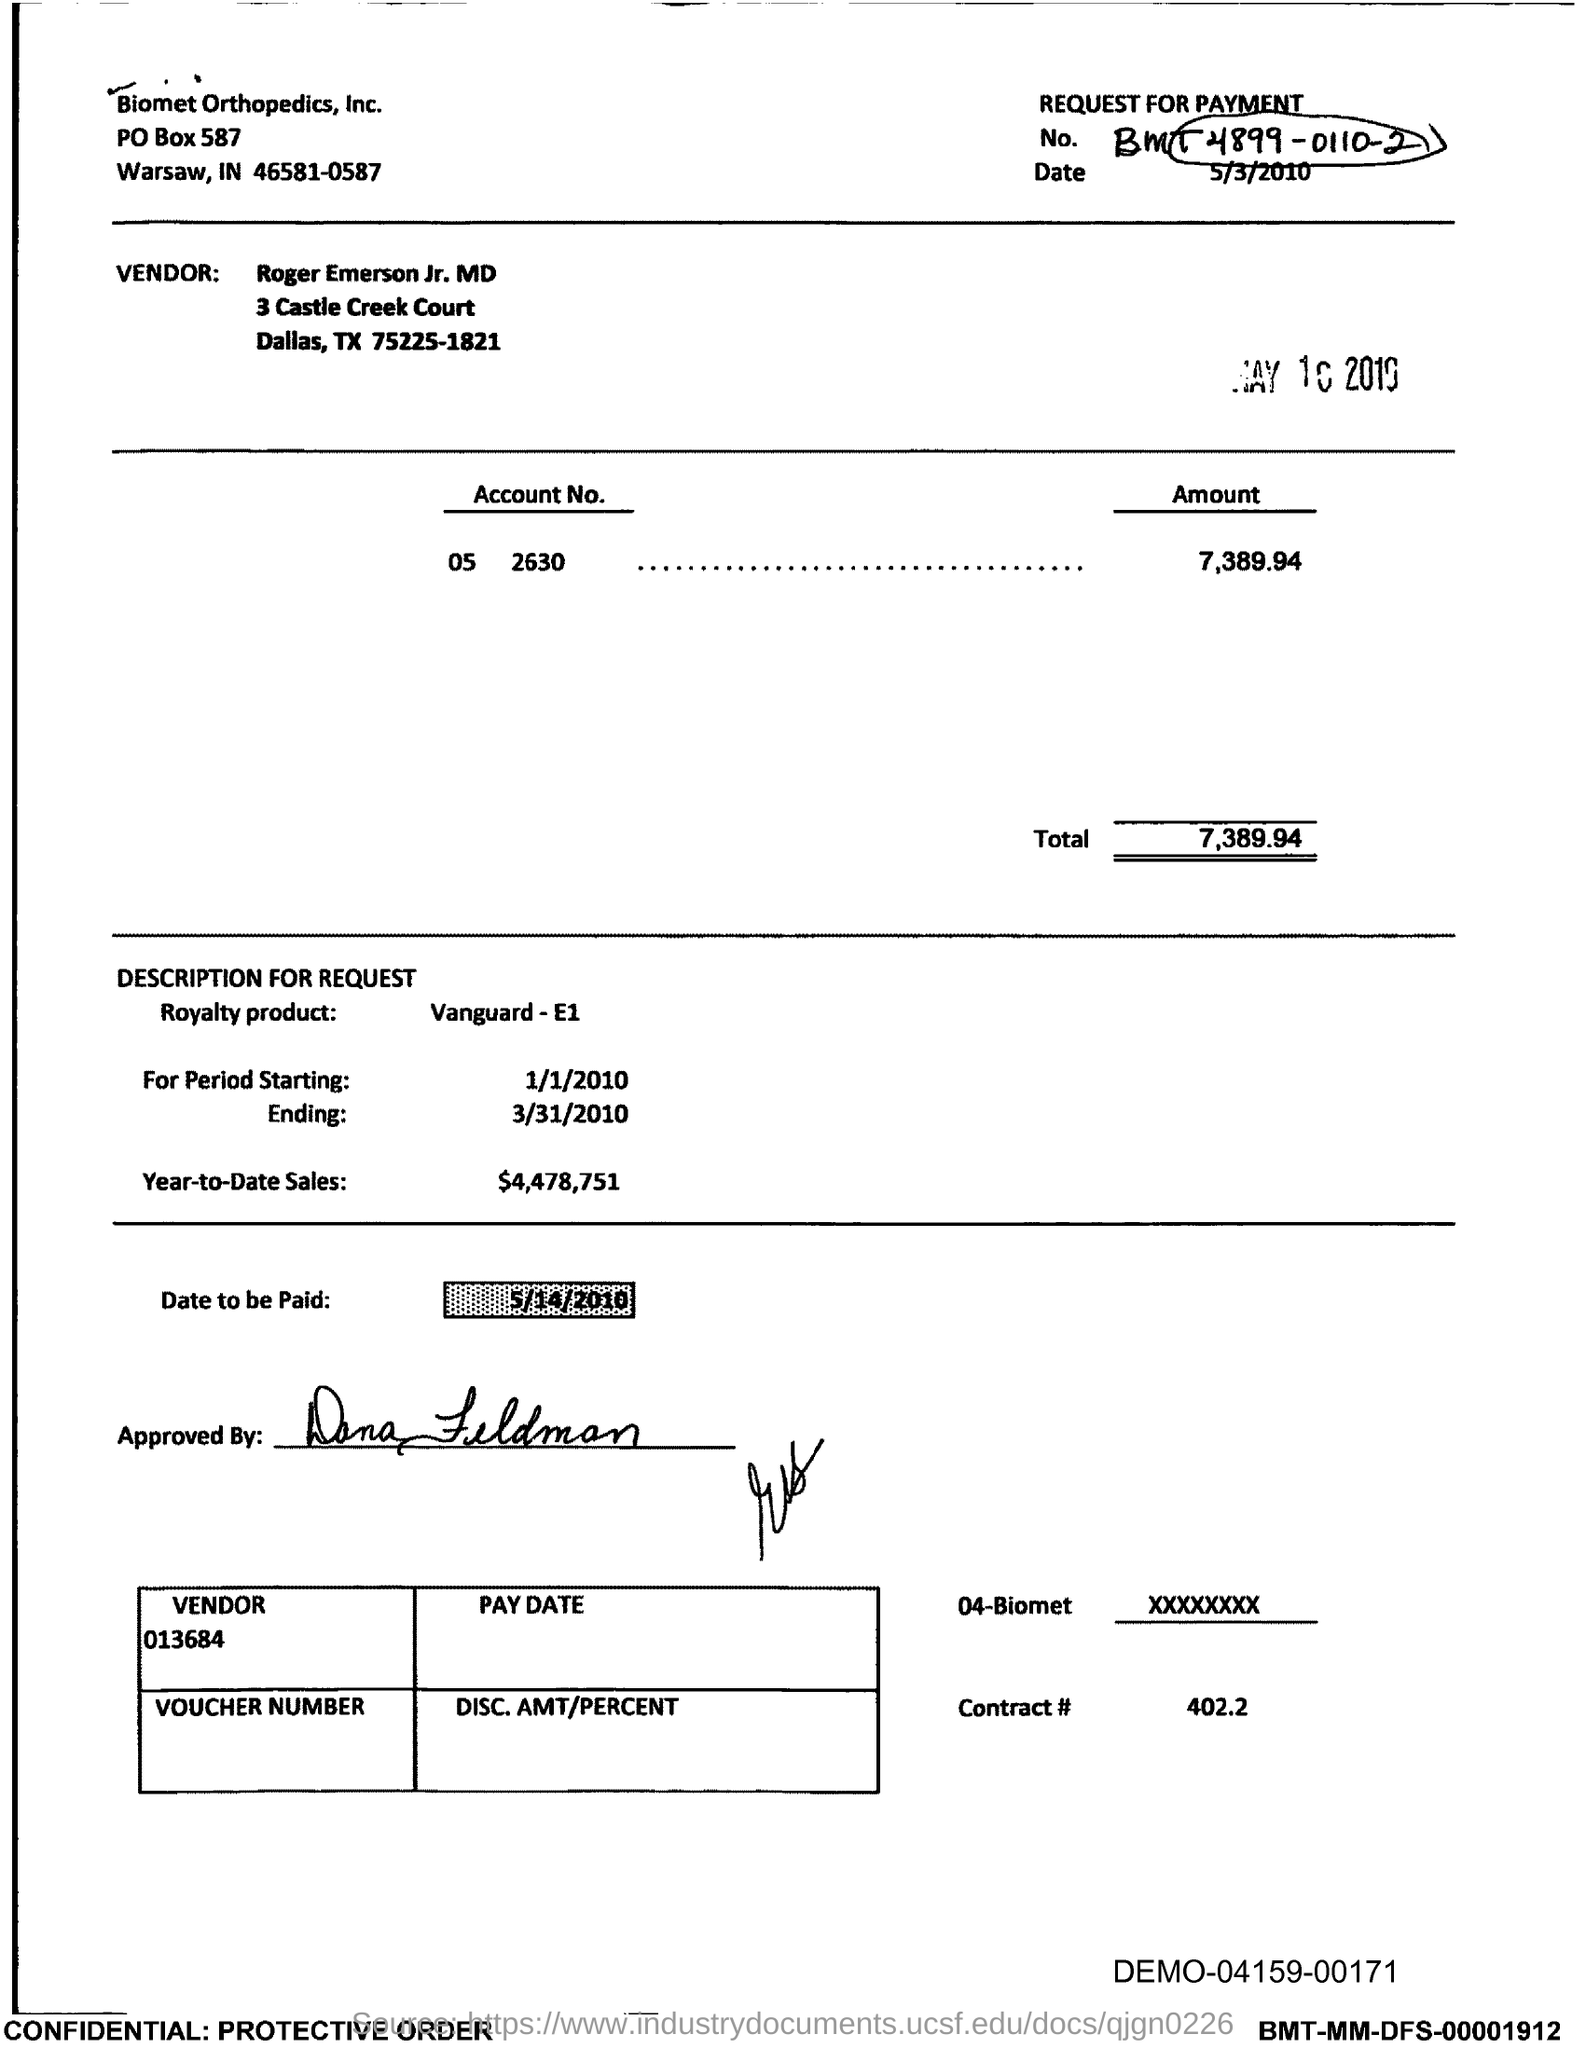List a handful of essential elements in this visual. The total is 7,389.94, including any decimals. The PO Box number mentioned in the document is 587. 